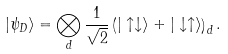<formula> <loc_0><loc_0><loc_500><loc_500>| \psi _ { D } \rangle = \bigotimes _ { d } \frac { 1 } { \sqrt { 2 } } \left ( | \uparrow \downarrow \rangle + | \downarrow \uparrow \rangle \right ) _ { d } .</formula> 